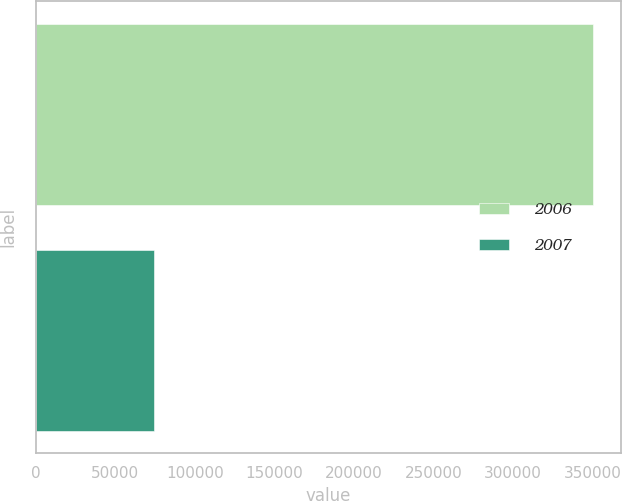Convert chart. <chart><loc_0><loc_0><loc_500><loc_500><bar_chart><fcel>2006<fcel>2007<nl><fcel>350372<fcel>74091<nl></chart> 